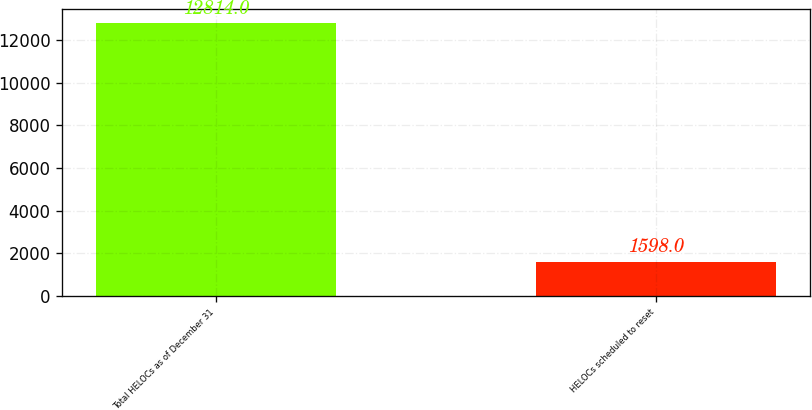<chart> <loc_0><loc_0><loc_500><loc_500><bar_chart><fcel>Total HELOCs as of December 31<fcel>HELOCs scheduled to reset<nl><fcel>12814<fcel>1598<nl></chart> 